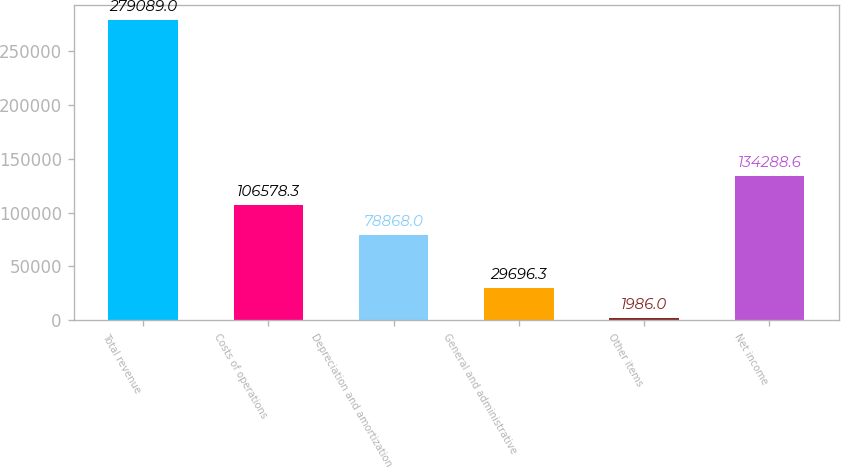Convert chart to OTSL. <chart><loc_0><loc_0><loc_500><loc_500><bar_chart><fcel>Total revenue<fcel>Costs of operations<fcel>Depreciation and amortization<fcel>General and administrative<fcel>Other items<fcel>Net income<nl><fcel>279089<fcel>106578<fcel>78868<fcel>29696.3<fcel>1986<fcel>134289<nl></chart> 